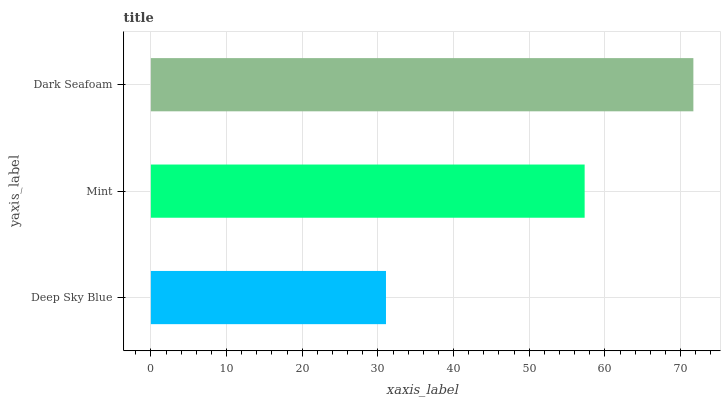Is Deep Sky Blue the minimum?
Answer yes or no. Yes. Is Dark Seafoam the maximum?
Answer yes or no. Yes. Is Mint the minimum?
Answer yes or no. No. Is Mint the maximum?
Answer yes or no. No. Is Mint greater than Deep Sky Blue?
Answer yes or no. Yes. Is Deep Sky Blue less than Mint?
Answer yes or no. Yes. Is Deep Sky Blue greater than Mint?
Answer yes or no. No. Is Mint less than Deep Sky Blue?
Answer yes or no. No. Is Mint the high median?
Answer yes or no. Yes. Is Mint the low median?
Answer yes or no. Yes. Is Dark Seafoam the high median?
Answer yes or no. No. Is Deep Sky Blue the low median?
Answer yes or no. No. 